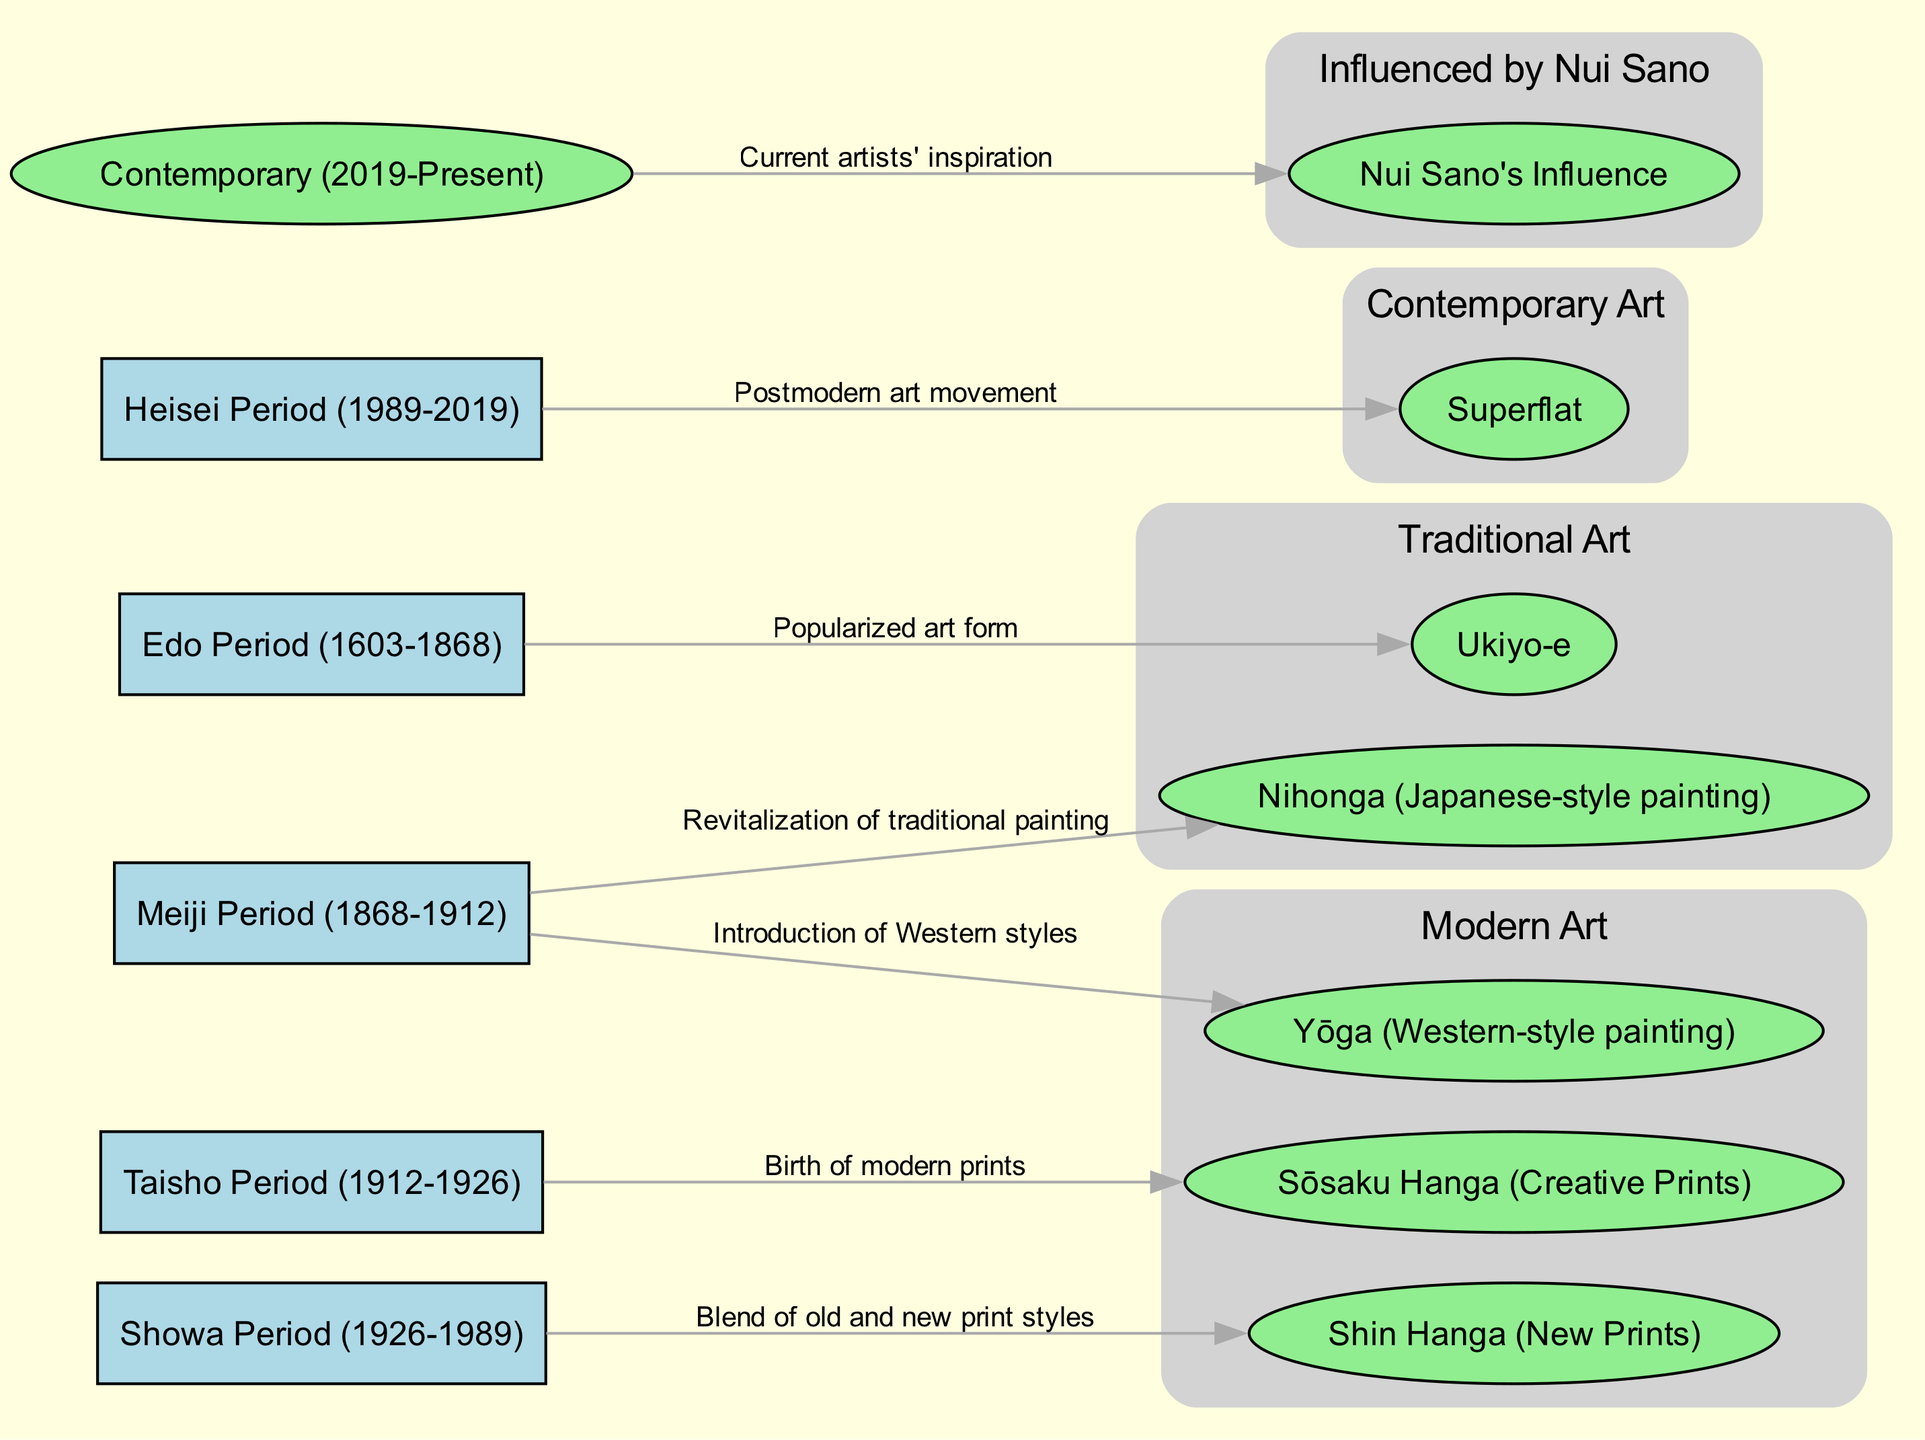What is the earliest art movement represented in the diagram? The diagram starts with the Edo Period and includes Ukiyo-e, which is represented as an art form that was popularized during this time. Hence, Ukiyo-e is connected to the Edo Period as the earliest art movement.
Answer: Ukiyo-e How many edges are there in the diagram? The diagram has a total of six edges that depict the relationships between the art movements and their characteristics. Counting the edges listed, one can confirm that there are six direct connections.
Answer: 6 What art movement was introduced during the Meiji Period? The diagram shows two movements linked to the Meiji Period: Yōga and Nihonga. Therefore, both movements were introduced during this period, but focusing on the first introduced style, we see that Yōga represents the introduction of Western styles.
Answer: Yōga Which period is associated with the birth of Sōsaku Hanga? The diagram clearly indicates that the Sōsaku Hanga movement originated during the Taisho Period, as this connection is explicitly stated with an arrow linking the two.
Answer: Taisho Period What does the contemporary art movement relate to in the diagram? The diagram connects the contemporary period to Nui Sano's influence, as indicated by the direct edge leading from the contemporary node to the Nui Sano influence node.
Answer: Nui Sano's Influence How are traditional and modern art movements categorized in the diagram? The diagram shows two distinct sets: Traditional Art includes Ukiyo-e and Nihonga, while Modern Art consists of Yōga, Sōsaku Hanga, and Shin Hanga. This classification highlights the differences based on the styles and historical context of the movements.
Answer: Traditional Art and Modern Art What kind of relationship is depicted between the Showa Period and Shin Hanga? The relationship illustrated indicates a blending of old and new print styles during the Showa Period, as presented with a direct edge connecting both elements in the diagram, clearly showcasing the influence of historical context on Shin Hanga.
Answer: Blend of old and new print styles Which contemporary art movement emerged during the Heisei Period? The Superflat movement is indicated in the diagram to have emerged during the Heisei Period, as it is directly linked with that period in the flow of the diagram, showing its connection to postmodern art.
Answer: Superflat Which traditional Japanese art forms are shown in the diagram? The diagram specifically lists Ukiyo-e and Nihonga as part of the Traditional Art set, clearly categorizing these forms under historical Japanese art styles.
Answer: Ukiyo-e and Nihonga 